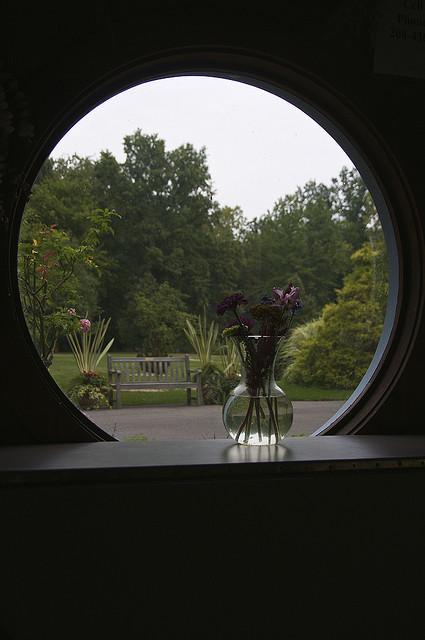What is the jar filled with?
Concise answer only. Water. Where would you sit in this picture?
Answer briefly. Bench. What is unusual about the window?
Be succinct. Round. 